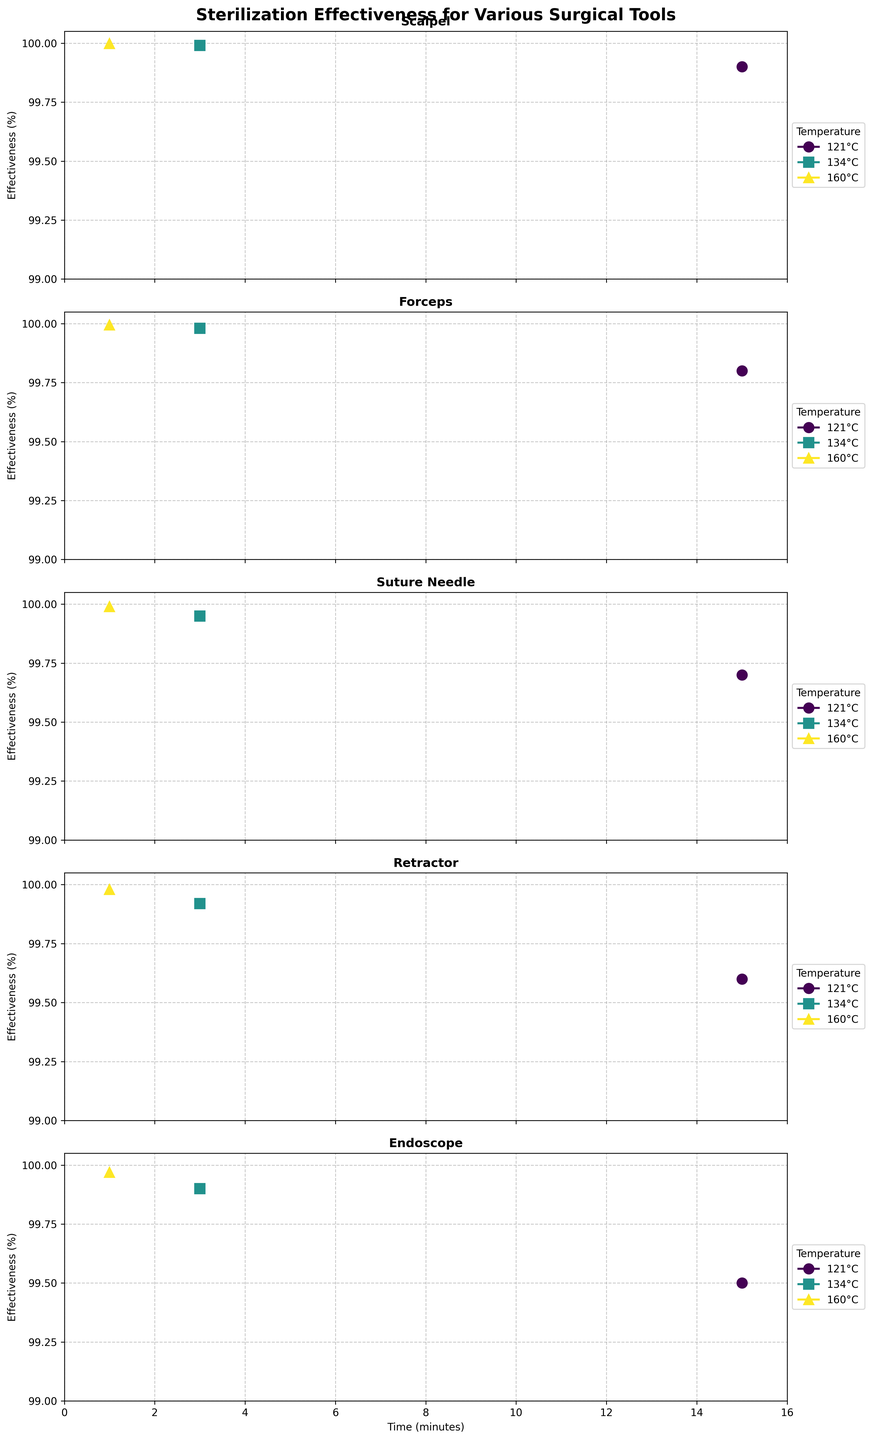What's the title of the figure? The figure's title is placed at the top in bold. By reading it directly, we can determine the title.
Answer: Sterilization Effectiveness for Various Surgical Tools What is the range of the y-axis ticks in the subplots? By observing the y-axis on each subplot, we can see the labeled ticks and their values.
Answer: 99 to 100 Which tool shows the highest sterilization effectiveness at 121°C and 15 minutes? By scanning the subplots for sterilization effectiveness at 121°C and 15 minutes, compare the values to determine the highest one.
Answer: Scalpel Out of all the tools, which has the lowest sterilization effectiveness at 160°C for 1 minute? Review each subplot at 160°C for 1 minute, identifying the lowest sterilization effectiveness value among all tools.
Answer: Endoscope Comparing the Scalpel and Forceps, which tool has higher sterilization effectiveness at 134°C for 3 minutes? Look at the subplots for Scalpel and Forceps at 134°C for 3 minutes and compare their effectiveness values.
Answer: Scalpel What is the temperature that shows the highest effectiveness consistently across all tools? Check the sterilization effectiveness for each temperature in all subplots and identify the temperature with the highest values.
Answer: 160°C How does the sterilization effectiveness of a Suture Needle at 121°C for 15 minutes compare to that at 134°C for 3 minutes? Compare the effectiveness percentages from the Suture Needle subplot for both specified conditions.
Answer: Lower at 121°C for 15 minutes What common pattern is observed as the temperature increases for each tool? Examine each subplot, noting the trend in sterilization effectiveness as the temperature increases.
Answer: Effectiveness increases Which tool has the greatest increase in effectiveness from 121°C to 134°C? Identify and compare the increase in sterilization effectiveness from 121°C to 134°C for each tool.
Answer: Suture Needle Which tool has the most consistent sterilization effectiveness across all temperatures? Assess the range of sterilization effectiveness for each tool across different temperatures to find the most consistent one.
Answer: Scalpel 